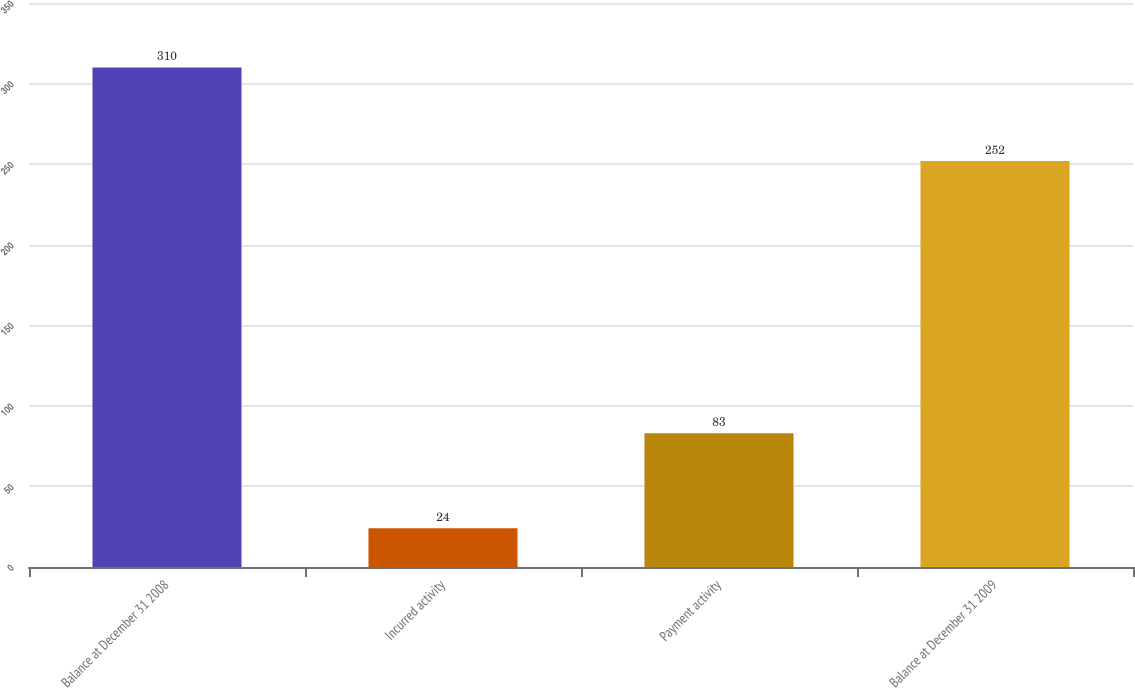Convert chart. <chart><loc_0><loc_0><loc_500><loc_500><bar_chart><fcel>Balance at December 31 2008<fcel>Incurred activity<fcel>Payment activity<fcel>Balance at December 31 2009<nl><fcel>310<fcel>24<fcel>83<fcel>252<nl></chart> 